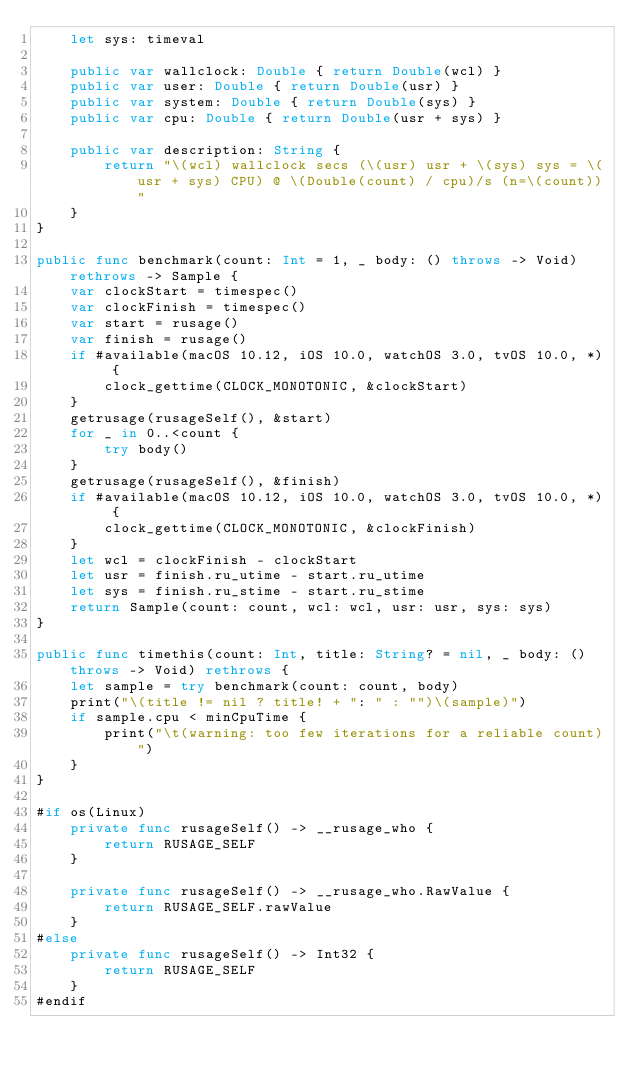Convert code to text. <code><loc_0><loc_0><loc_500><loc_500><_Swift_>	let sys: timeval

	public var wallclock: Double { return Double(wcl) }
	public var user: Double { return Double(usr) }
	public var system: Double { return Double(sys) }
	public var cpu: Double { return Double(usr + sys) }

	public var description: String {
		return "\(wcl) wallclock secs (\(usr) usr + \(sys) sys = \(usr + sys) CPU) @ \(Double(count) / cpu)/s (n=\(count))"
	}
}

public func benchmark(count: Int = 1, _ body: () throws -> Void) rethrows -> Sample {
	var clockStart = timespec()
	var clockFinish = timespec()
	var start = rusage()
	var finish = rusage()
	if #available(macOS 10.12, iOS 10.0, watchOS 3.0, tvOS 10.0, *) {
		clock_gettime(CLOCK_MONOTONIC, &clockStart)
	}
	getrusage(rusageSelf(), &start)
	for _ in 0..<count {
		try body()
	}
	getrusage(rusageSelf(), &finish)
	if #available(macOS 10.12, iOS 10.0, watchOS 3.0, tvOS 10.0, *) {
		clock_gettime(CLOCK_MONOTONIC, &clockFinish)
	}
	let wcl = clockFinish - clockStart
	let usr = finish.ru_utime - start.ru_utime
	let sys = finish.ru_stime - start.ru_stime
	return Sample(count: count, wcl: wcl, usr: usr, sys: sys)
}

public func timethis(count: Int, title: String? = nil, _ body: () throws -> Void) rethrows {
	let sample = try benchmark(count: count, body)
	print("\(title != nil ? title! + ": " : "")\(sample)")
	if sample.cpu < minCpuTime {
		print("\t(warning: too few iterations for a reliable count)")
	}
}

#if os(Linux)
	private func rusageSelf() -> __rusage_who {
		return RUSAGE_SELF
	}

	private func rusageSelf() -> __rusage_who.RawValue {
		return RUSAGE_SELF.rawValue
	}
#else
	private func rusageSelf() -> Int32 {
		return RUSAGE_SELF
	}
#endif
</code> 